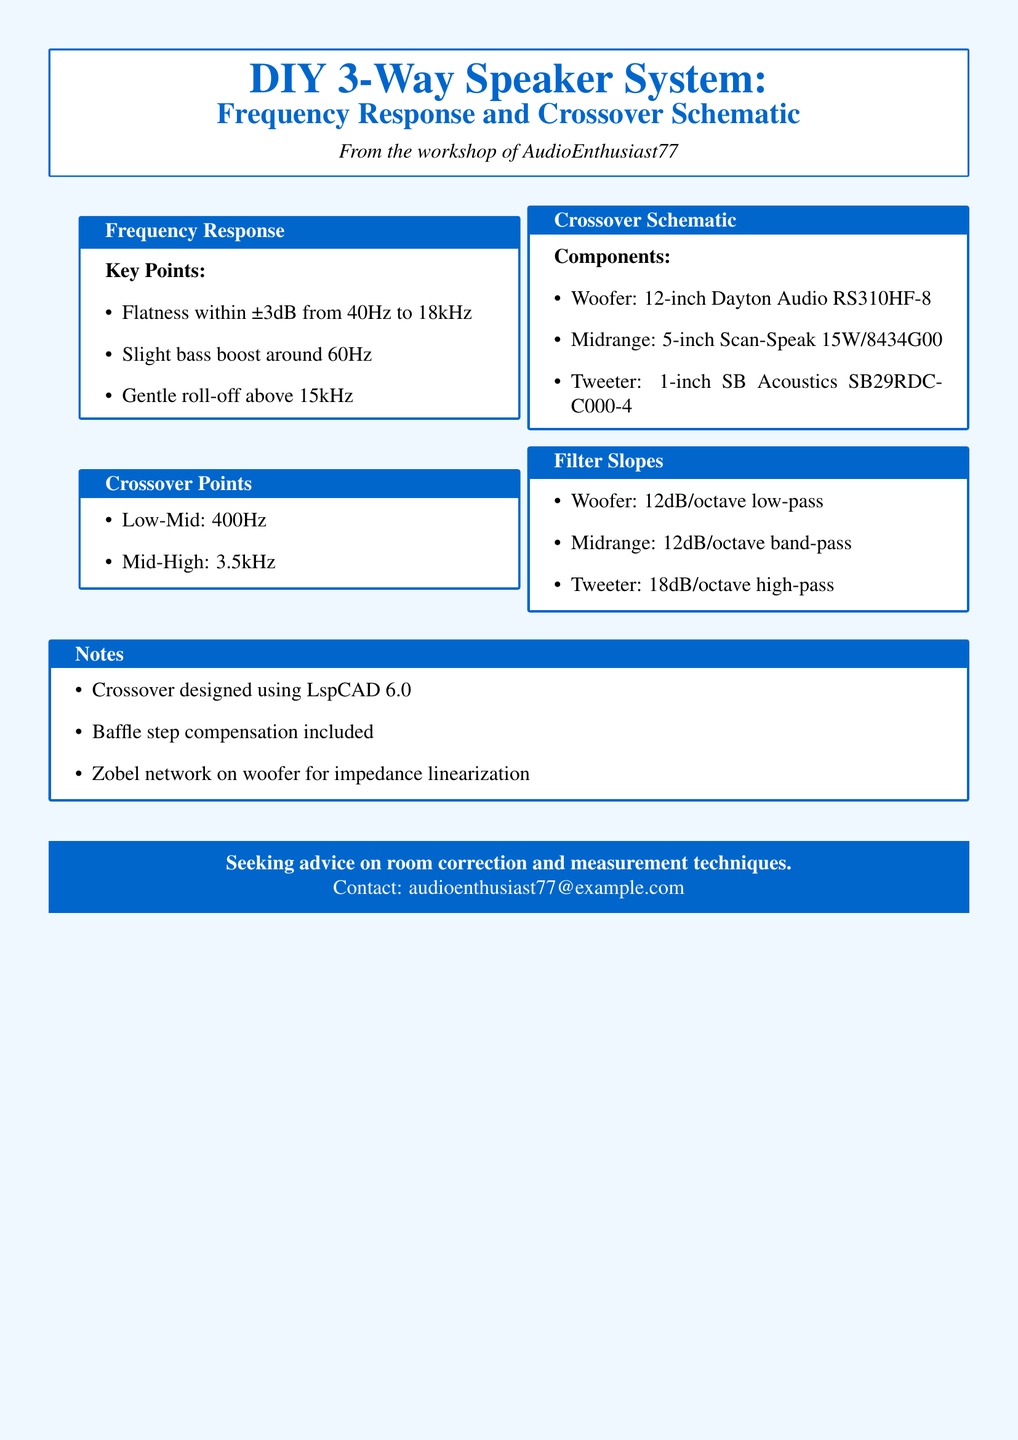what is the frequency response range? The frequency response is specified to be flat within ±3dB from 40Hz to 18kHz.
Answer: ±3dB from 40Hz to 18kHz what is the crossover point for the low-mid range? The crossover point for the low-mid range is listed as 400Hz in the document.
Answer: 400Hz how many drivers are used in the speaker system? The document lists three drivers; a woofer, a midrange, and a tweeter.
Answer: three what type of crossover was used for the woofer? The document specifies that a 12dB/octave low-pass filter is used for the woofer.
Answer: 12dB/octave low-pass which component has a 1-inch diameter? The tweeter is identified as having a 1-inch size in the document.
Answer: tweeter what is included for impedance linearization? The document mentions a Zobel network on the woofer for impedance linearization.
Answer: Zobel network what is the filter slope for the tweeter? The filter slope for the tweeter is specified as 18dB/octave high-pass.
Answer: 18dB/octave high-pass who is the author of the document? The document credits AudioEnthusiast77 as the author.
Answer: AudioEnthusiast77 what design tool was used for the crossover? The document states that the crossover was designed using LspCAD 6.0.
Answer: LspCAD 6.0 what email address is provided for seeking advice? The document provides the email address audioenthusiast77@example.com for inquiries.
Answer: audioenthusiast77@example.com 